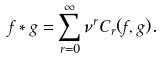<formula> <loc_0><loc_0><loc_500><loc_500>f \ast g = \sum _ { r = 0 } ^ { \infty } \nu ^ { r } C _ { r } ( f , g ) .</formula> 